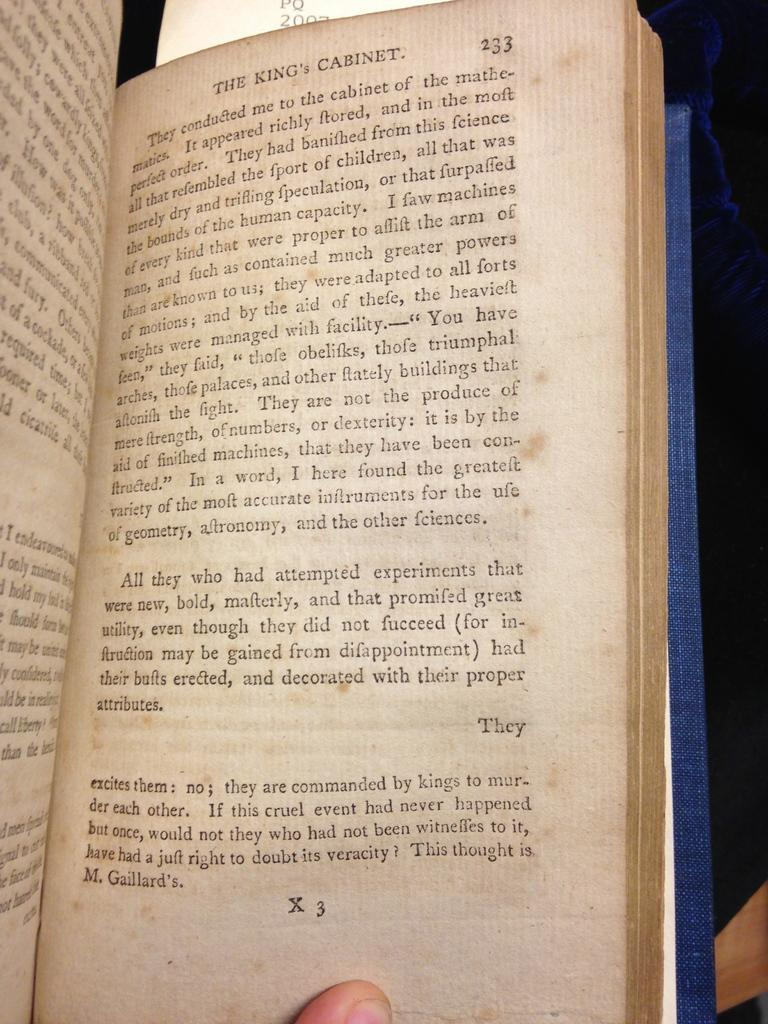<image>
Offer a succinct explanation of the picture presented. An old book opened to page 233 of The King's Cabinet. 